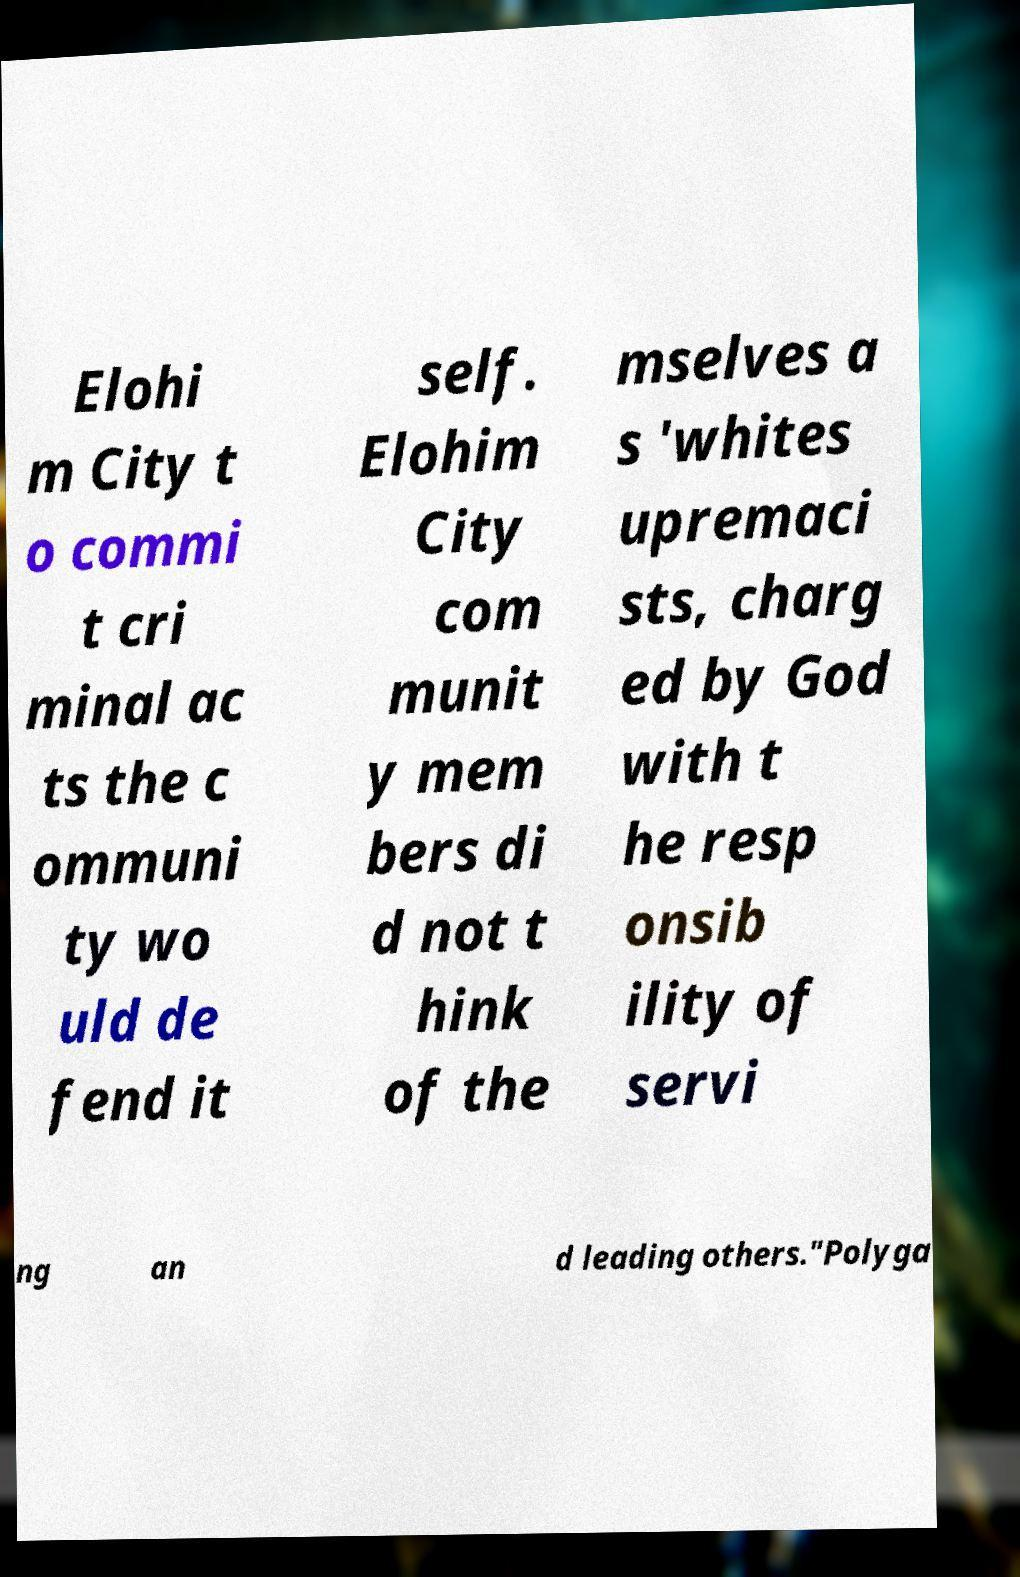Could you extract and type out the text from this image? Elohi m City t o commi t cri minal ac ts the c ommuni ty wo uld de fend it self. Elohim City com munit y mem bers di d not t hink of the mselves a s 'whites upremaci sts, charg ed by God with t he resp onsib ility of servi ng an d leading others."Polyga 